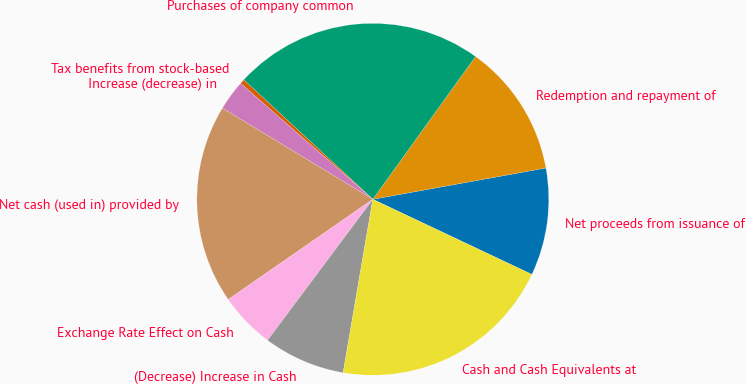<chart> <loc_0><loc_0><loc_500><loc_500><pie_chart><fcel>Net proceeds from issuance of<fcel>Redemption and repayment of<fcel>Purchases of company common<fcel>Tax benefits from stock-based<fcel>Increase (decrease) in<fcel>Net cash (used in) provided by<fcel>Exchange Rate Effect on Cash<fcel>(Decrease) Increase in Cash<fcel>Cash and Cash Equivalents at<nl><fcel>9.87%<fcel>12.23%<fcel>23.04%<fcel>0.43%<fcel>2.79%<fcel>18.32%<fcel>5.15%<fcel>7.51%<fcel>20.68%<nl></chart> 